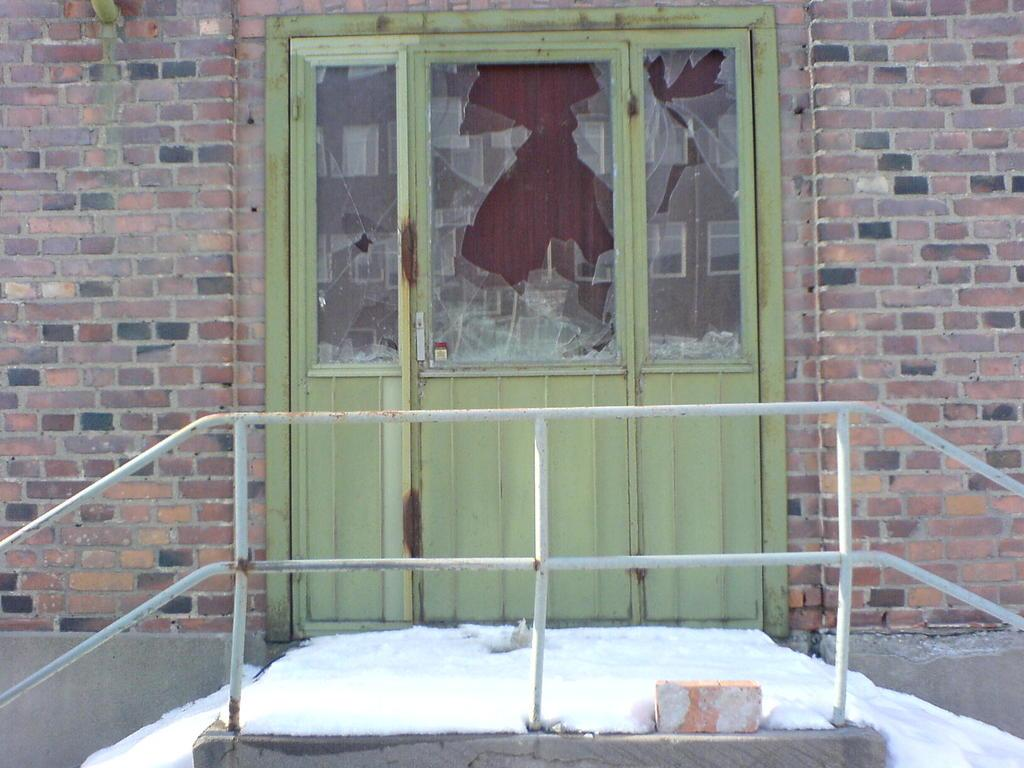What type of structure is present in the image? There is a building in the image. Where is the main entrance to the building located? There is a door in the center of the building. What feature is present at the bottom of the building? There is a railing at the bottom of the building. What weather condition is depicted in the image? Snow is visible in the image. Can you identify any specific object in the image? There is a brick in the image. What type of horse can be seen in the image? There is no horse present in the image. How many cups are visible in the image? There are no cups visible in the image. 